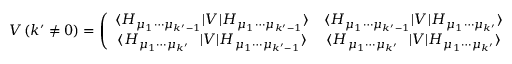<formula> <loc_0><loc_0><loc_500><loc_500>V \left ( k ^ { \prime } \ne 0 \right ) = \left ( \begin{array} { c c } { { \langle H _ { \mu _ { 1 } \cdots \mu _ { k ^ { \prime } - 1 } } | V | H _ { \mu _ { 1 } \cdots \mu _ { k ^ { \prime } - 1 } } \rangle } } & { { \langle H _ { \mu _ { 1 } \cdots \mu _ { k ^ { \prime } - 1 } } | V | H _ { \mu _ { 1 } \cdots \mu _ { k ^ { \prime } } } \rangle } } \\ { { \langle H _ { \mu _ { 1 } \cdots \mu _ { k ^ { \prime } } } | V | H _ { \mu _ { 1 } \cdots \mu _ { k ^ { \prime } - 1 } } \rangle } } & { { \langle H _ { \mu _ { 1 } \cdots \mu _ { k ^ { \prime } } } | V | { H } _ { \mu _ { 1 } \cdots \mu _ { k ^ { \prime } } } \rangle } } \end{array} \right ) \ .</formula> 